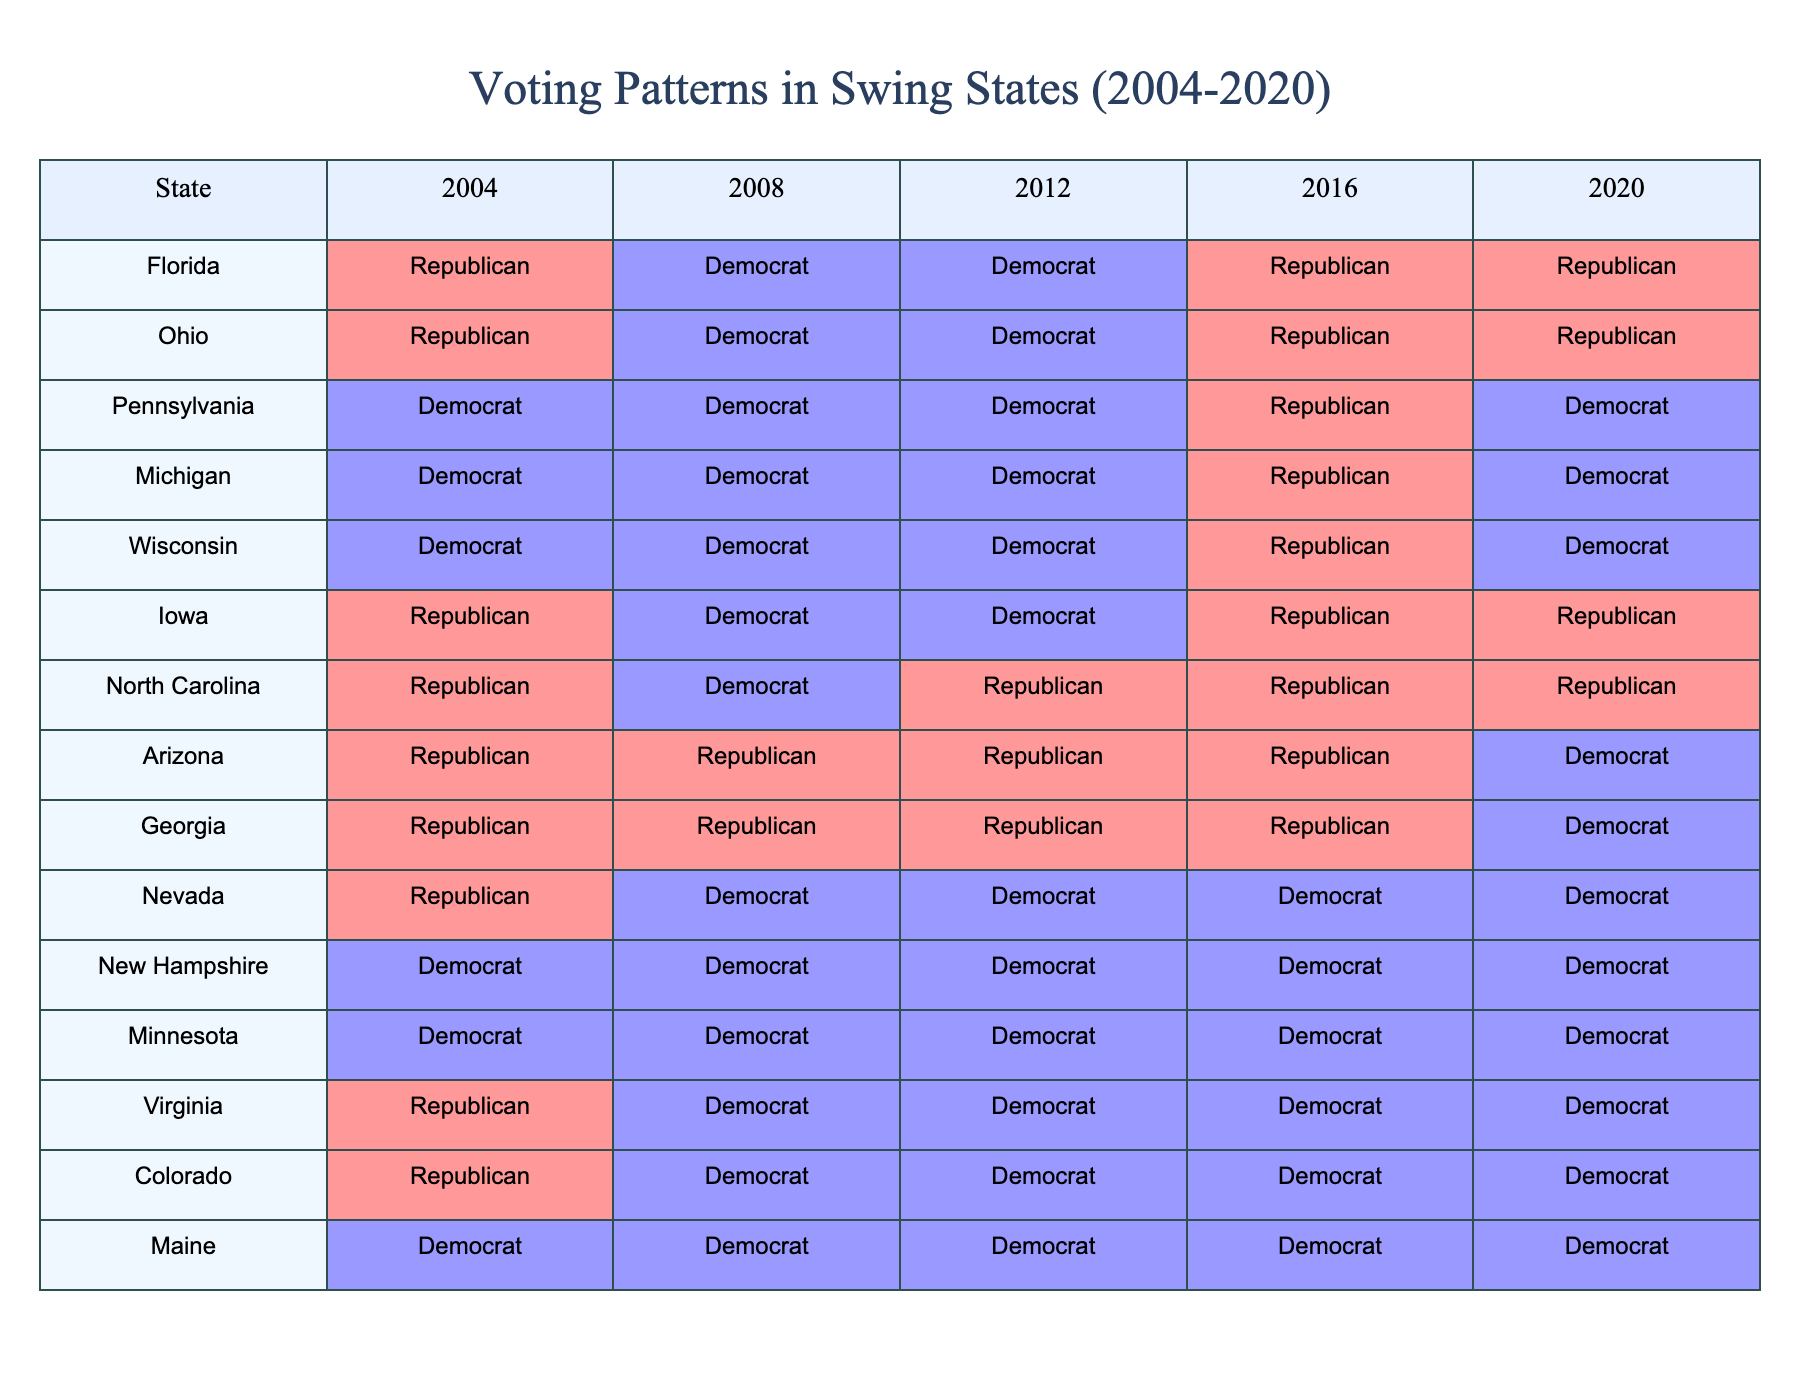What party won Florida in 2004? According to the table, Florida voted for the Republican party in 2004.
Answer: Republican Which party consistently won Vermont from 2004 to 2020? The table does not include Vermont; therefore, we cannot determine its voting pattern.
Answer: Not applicable What was the voting pattern in Pennsylvania from 2004 to 2020? Pennsylvania started as a Democratic state in 2004 and consistently voted Democrat until 2016, where it switched to Republican, then back to Democrat in 2020.
Answer: Democrat, Democrat, Democrat, Republican, Democrat Which states had a Democratic win in 2020? Examining the table, the states that voted Democrat in 2020 are Pennsylvania, Michigan, Wisconsin, Nevada, New Hampshire, Minnesota, Virginia, and Colorado.
Answer: Pennsylvania, Michigan, Wisconsin, Nevada, New Hampshire, Minnesota, Virginia, Colorado How many times did Michigan vote for the Democratic party between 2004 and 2016? Looking at the table, Michigan voted Democrat three times from 2004 to 2016 (2004, 2008, 2012).
Answer: 3 True or False: Arizona voted for the Republican party in 2020. In the table, Arizona is marked as Democrat for 2020, so the statement is false.
Answer: False What is the trend in Iowa's voting from 2004 to 2020? Iowa's voting switched between Republican and Democrat, starting Republican in 2004, turning Democrat in 2008, then Democrat again in 2012, then Republican in 2016, and finally Republican again in 2020.
Answer: Alternating trend Which state had the highest proportion of Democratic votes between 2004 and 2020? Examining the table, states like Minnesota and New Hampshire voted Democrat in all five elections. Thus, they have the highest proportion of Democratic votes.
Answer: Minnesota, New Hampshire From the table, which party had more wins in Ohio between 2004 and 2020? Ohio voted Republican in 2004, then switched to Democrat in 2008, Democrat in 2012, Republican in 2016, and Republican in 2020, giving Republicans three total wins and Democrats two.
Answer: Republican What is the total number of Democratic wins in swing states over the five elections (2004-2020)? By summing up the Democrat wins across the swing states from 2004 to 2020, we can count 15 Democrat wins overall.
Answer: 15 